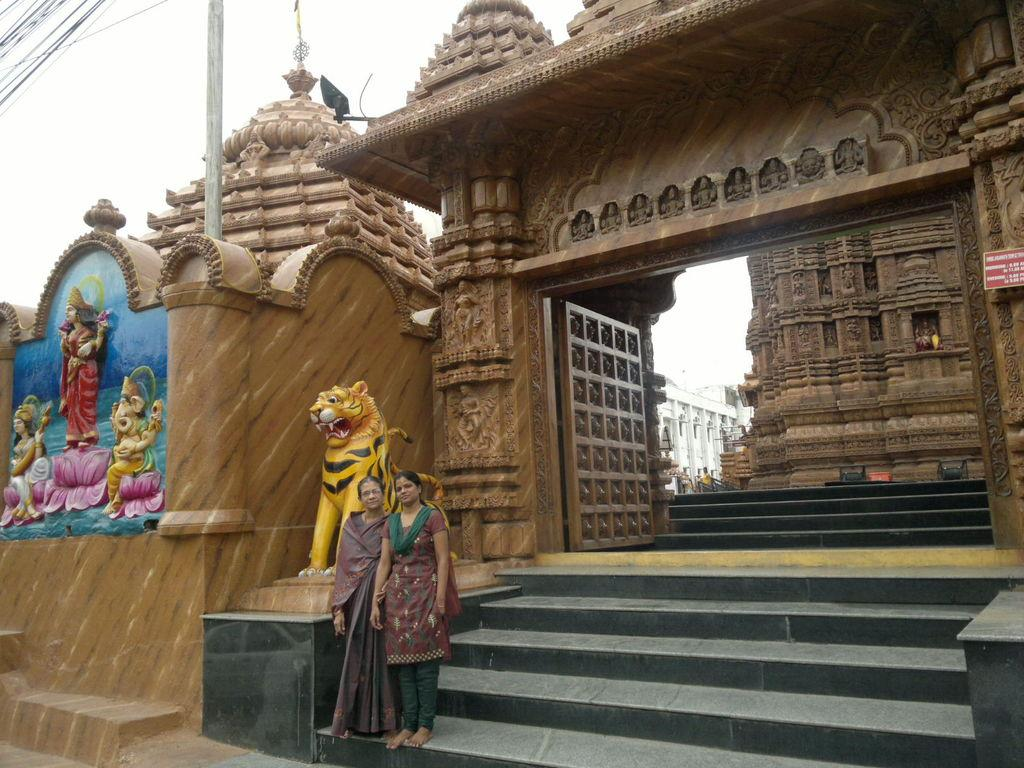What type of structure is shown in the image? The image depicts a temple. How many people are in the image? There are two people in the image. What are the people doing in front of the temple? The people are standing in front of a lion statue and posing for a photo. Where are the people located in relation to the temple? The people are at the entrance of the temple. What type of laborer is working on the temple in the image? There is no laborer working on the temple in the image; it is a photograph of people posing for a photo at the entrance of the temple. What type of jewel is present in the image? There is no jewel present in the image. 